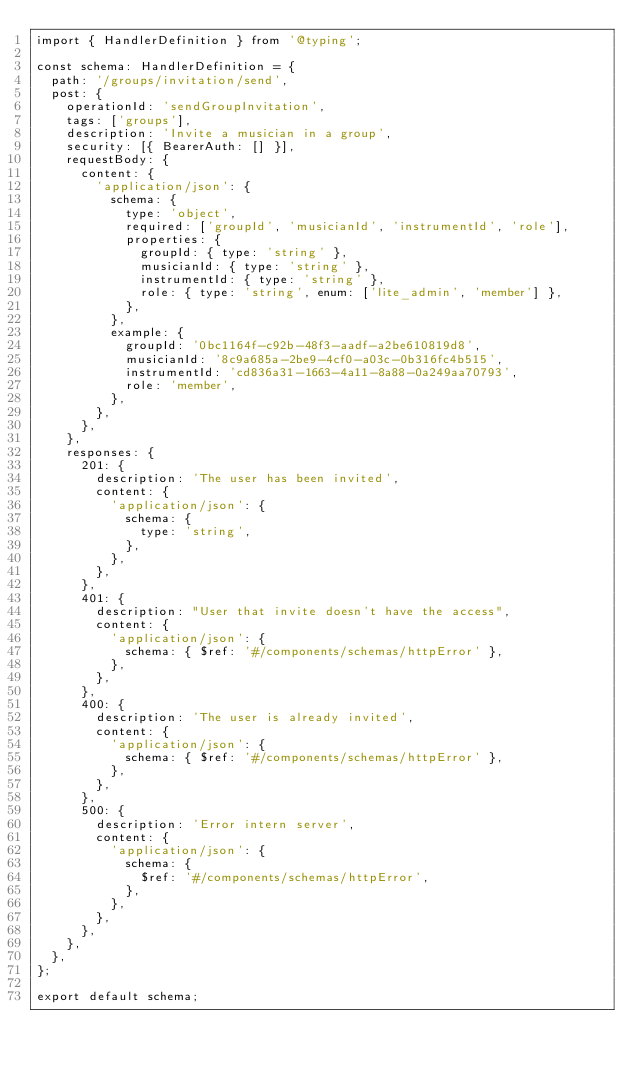<code> <loc_0><loc_0><loc_500><loc_500><_TypeScript_>import { HandlerDefinition } from '@typing';

const schema: HandlerDefinition = {
  path: '/groups/invitation/send',
  post: {
    operationId: 'sendGroupInvitation',
    tags: ['groups'],
    description: 'Invite a musician in a group',
    security: [{ BearerAuth: [] }],
    requestBody: {
      content: {
        'application/json': {
          schema: {
            type: 'object',
            required: ['groupId', 'musicianId', 'instrumentId', 'role'],
            properties: {
              groupId: { type: 'string' },
              musicianId: { type: 'string' },
              instrumentId: { type: 'string' },
              role: { type: 'string', enum: ['lite_admin', 'member'] },
            },
          },
          example: {
            groupId: '0bc1164f-c92b-48f3-aadf-a2be610819d8',
            musicianId: '8c9a685a-2be9-4cf0-a03c-0b316fc4b515',
            instrumentId: 'cd836a31-1663-4a11-8a88-0a249aa70793',
            role: 'member',
          },
        },
      },
    },
    responses: {
      201: {
        description: 'The user has been invited',
        content: {
          'application/json': {
            schema: {
              type: 'string',
            },
          },
        },
      },
      401: {
        description: "User that invite doesn't have the access",
        content: {
          'application/json': {
            schema: { $ref: '#/components/schemas/httpError' },
          },
        },
      },
      400: {
        description: 'The user is already invited',
        content: {
          'application/json': {
            schema: { $ref: '#/components/schemas/httpError' },
          },
        },
      },
      500: {
        description: 'Error intern server',
        content: {
          'application/json': {
            schema: {
              $ref: '#/components/schemas/httpError',
            },
          },
        },
      },
    },
  },
};

export default schema;
</code> 